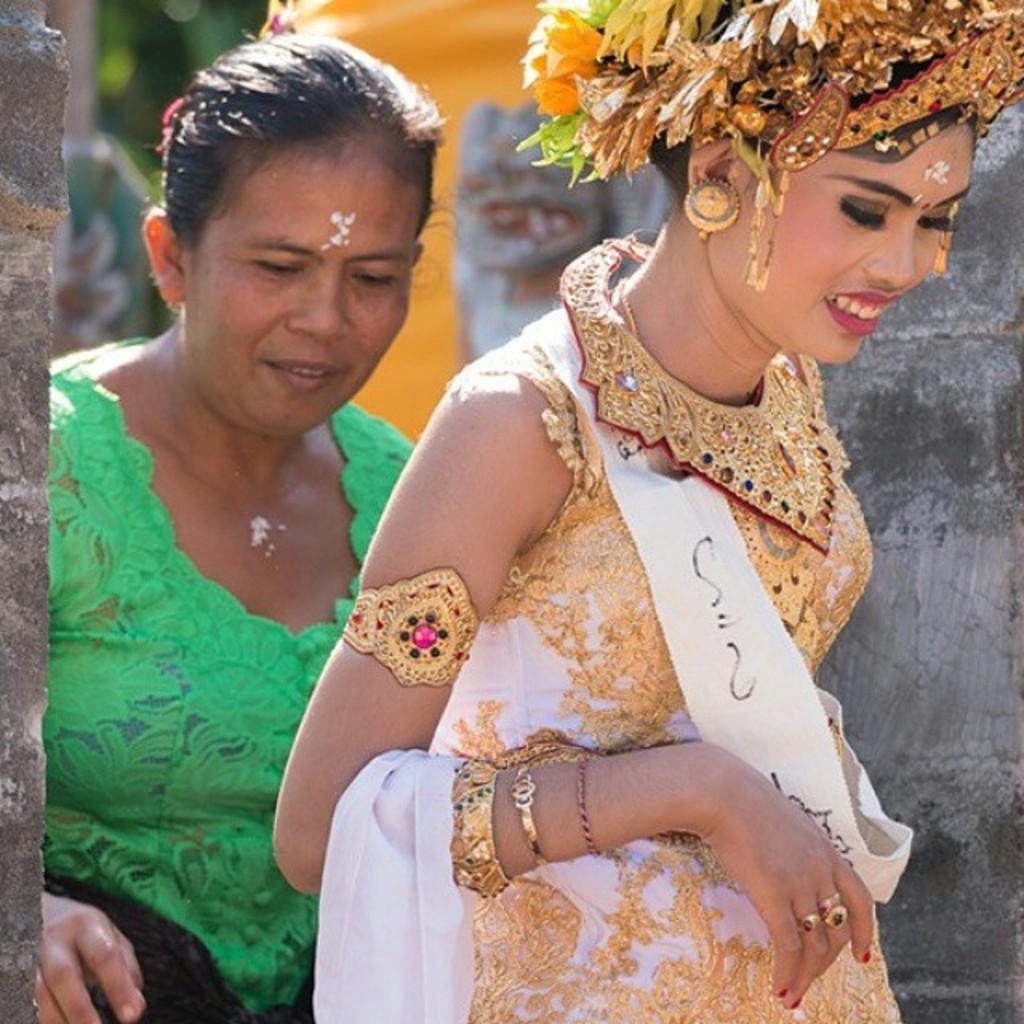Could you give a brief overview of what you see in this image? In this image I can see two women are standing and I can see one of them is wearing green dress and I can see she is wearing white and golden colour dress. I can also see few flowers on her head and I can see this image is little bit blurry from background. 